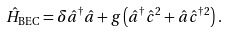<formula> <loc_0><loc_0><loc_500><loc_500>\hat { H } _ { \text {BEC} } = \delta \hat { a } ^ { \dagger } \hat { a } + g \left ( \hat { a } ^ { \dagger } \hat { c } ^ { 2 } + \hat { a } \hat { c } ^ { \dagger 2 } \right ) .</formula> 